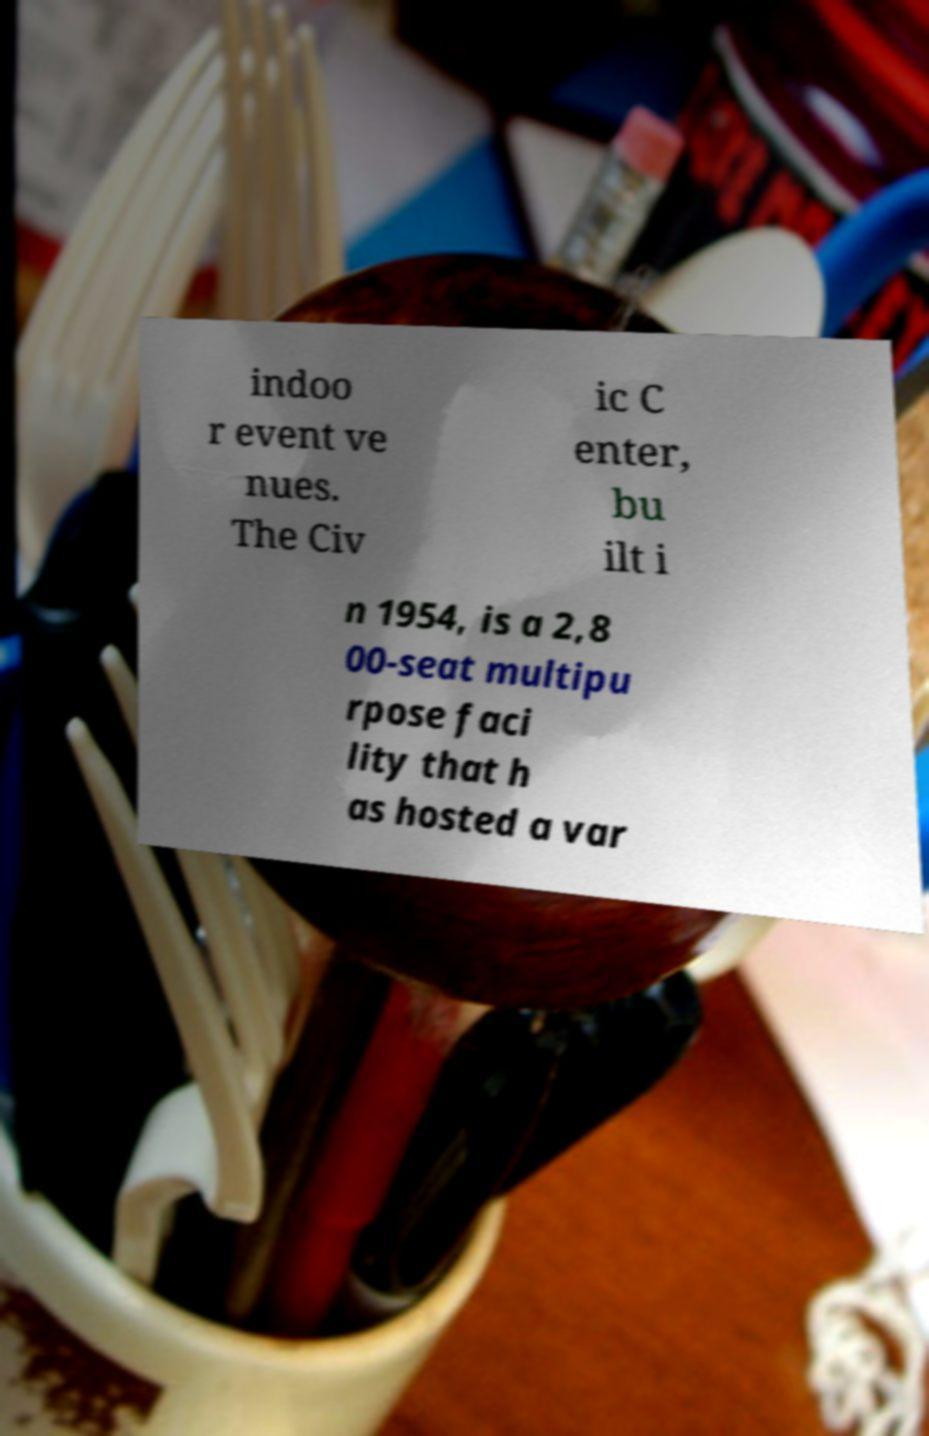There's text embedded in this image that I need extracted. Can you transcribe it verbatim? indoo r event ve nues. The Civ ic C enter, bu ilt i n 1954, is a 2,8 00-seat multipu rpose faci lity that h as hosted a var 